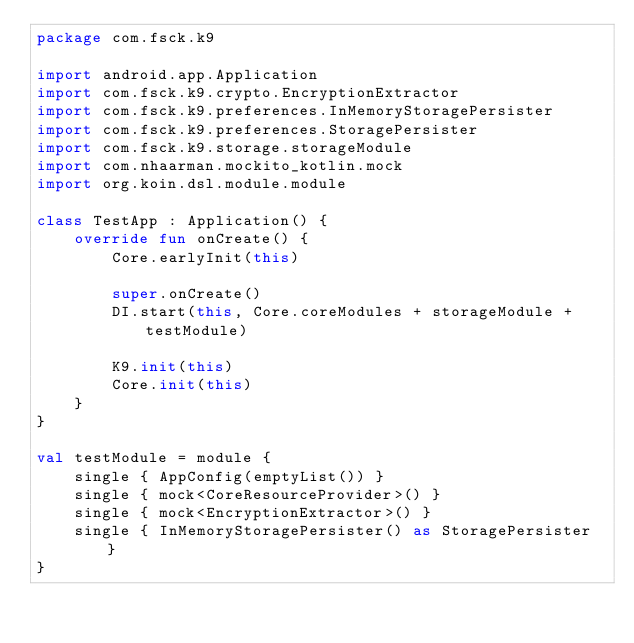<code> <loc_0><loc_0><loc_500><loc_500><_Kotlin_>package com.fsck.k9

import android.app.Application
import com.fsck.k9.crypto.EncryptionExtractor
import com.fsck.k9.preferences.InMemoryStoragePersister
import com.fsck.k9.preferences.StoragePersister
import com.fsck.k9.storage.storageModule
import com.nhaarman.mockito_kotlin.mock
import org.koin.dsl.module.module

class TestApp : Application() {
    override fun onCreate() {
        Core.earlyInit(this)

        super.onCreate()
        DI.start(this, Core.coreModules + storageModule + testModule)

        K9.init(this)
        Core.init(this)
    }
}

val testModule = module {
    single { AppConfig(emptyList()) }
    single { mock<CoreResourceProvider>() }
    single { mock<EncryptionExtractor>() }
    single { InMemoryStoragePersister() as StoragePersister }
}
</code> 